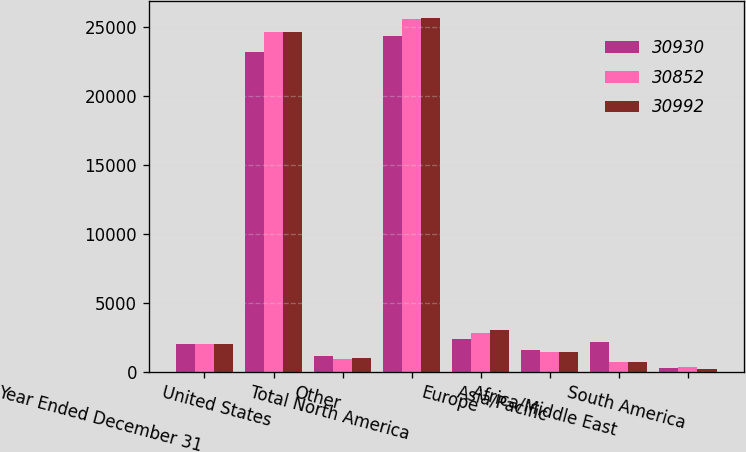Convert chart. <chart><loc_0><loc_0><loc_500><loc_500><stacked_bar_chart><ecel><fcel>Year Ended December 31<fcel>United States<fcel>Other<fcel>Total North America<fcel>Europe<fcel>Asia/Pacific<fcel>Africa/Middle East<fcel>South America<nl><fcel>30930<fcel>2014<fcel>23222<fcel>1174<fcel>24396<fcel>2410<fcel>1608<fcel>2163<fcel>275<nl><fcel>30852<fcel>2013<fcel>24646<fcel>959<fcel>25605<fcel>2795<fcel>1466<fcel>736<fcel>328<nl><fcel>30992<fcel>2012<fcel>24636<fcel>1035<fcel>25671<fcel>3013<fcel>1405<fcel>689<fcel>214<nl></chart> 